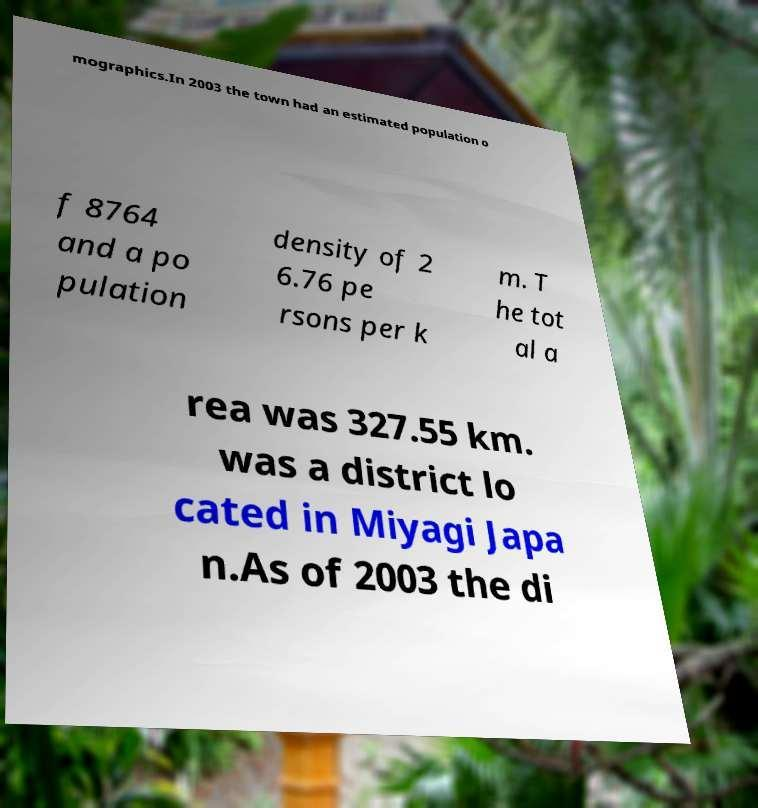Please read and relay the text visible in this image. What does it say? mographics.In 2003 the town had an estimated population o f 8764 and a po pulation density of 2 6.76 pe rsons per k m. T he tot al a rea was 327.55 km. was a district lo cated in Miyagi Japa n.As of 2003 the di 